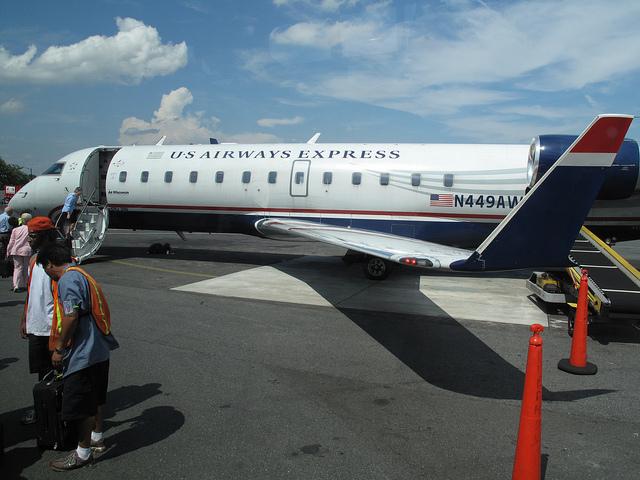What airline is this?
Keep it brief. Us airways express. How many people are wearing orange vests?
Short answer required. 2. Are there vehicles parked alongside the plane?
Quick response, please. No. Is this a government official's plane?
Write a very short answer. No. What is the country name on the side of the plane?
Answer briefly. Us. Is this a small plane or large plane?
Concise answer only. Large. What is written on the plane?
Short answer required. Us airways express. How many people in this shot?
Give a very brief answer. 4. Which country is the plane from?
Be succinct. United states. What airlines is this?
Be succinct. Us airways express. Is the jet pictured from China Airlines?
Quick response, please. No. How many planes are in the picture?
Be succinct. 1. How many full cones are viewable?
Keep it brief. 2. Why are there cones on side of the plane?
Quick response, please. Safety. How many passengers are currently leaving the plane?
Quick response, please. 0. What does it say on the airplane?
Short answer required. Us airways express. How many cones are in the picture?
Quick response, please. 2. What is the name of the white plane?
Keep it brief. Us airways express. Where is this airplane from?
Be succinct. Us. What airline is this aircraft?
Answer briefly. Us airways express. 